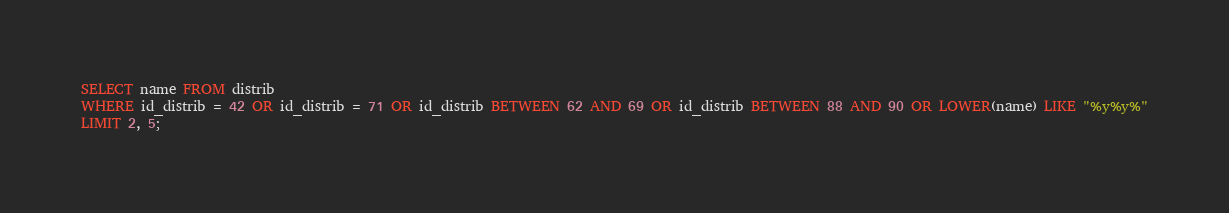Convert code to text. <code><loc_0><loc_0><loc_500><loc_500><_SQL_>SELECT name FROM distrib
WHERE id_distrib = 42 OR id_distrib = 71 OR id_distrib BETWEEN 62 AND 69 OR id_distrib BETWEEN 88 AND 90 OR LOWER(name) LIKE "%y%y%"
LIMIT 2, 5;
</code> 